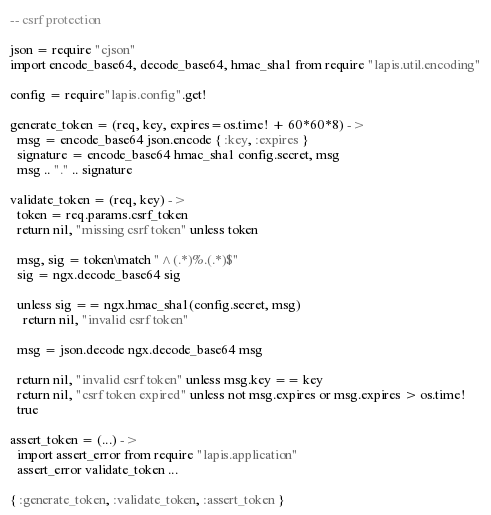<code> <loc_0><loc_0><loc_500><loc_500><_MoonScript_>
-- csrf protection

json = require "cjson"
import encode_base64, decode_base64, hmac_sha1 from require "lapis.util.encoding"

config = require"lapis.config".get!

generate_token = (req, key, expires=os.time! + 60*60*8) ->
  msg = encode_base64 json.encode { :key, :expires }
  signature = encode_base64 hmac_sha1 config.secret, msg
  msg .. "." .. signature

validate_token = (req, key) ->
  token = req.params.csrf_token
  return nil, "missing csrf token" unless token

  msg, sig = token\match "^(.*)%.(.*)$"
  sig = ngx.decode_base64 sig

  unless sig == ngx.hmac_sha1(config.secret, msg)
    return nil, "invalid csrf token"

  msg = json.decode ngx.decode_base64 msg

  return nil, "invalid csrf token" unless msg.key == key
  return nil, "csrf token expired" unless not msg.expires or msg.expires > os.time!
  true

assert_token = (...) ->
  import assert_error from require "lapis.application"
  assert_error validate_token ...

{ :generate_token, :validate_token, :assert_token }

</code> 